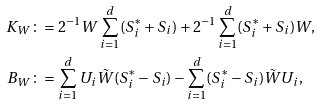Convert formula to latex. <formula><loc_0><loc_0><loc_500><loc_500>K _ { W } & \colon = 2 ^ { - 1 } W \sum _ { i = 1 } ^ { d } ( S _ { i } ^ { * } + S _ { i } ) + 2 ^ { - 1 } \sum _ { i = 1 } ^ { d } ( S _ { i } ^ { * } + S _ { i } ) W , \\ B _ { W } & \colon = \sum _ { i = 1 } ^ { d } U _ { i } \tilde { W } ( S _ { i } ^ { * } - S _ { i } ) - \sum _ { i = 1 } ^ { d } ( S _ { i } ^ { * } - S _ { i } ) \tilde { W } U _ { i } ,</formula> 